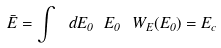Convert formula to latex. <formula><loc_0><loc_0><loc_500><loc_500>\bar { E } = \int \ d E _ { 0 } \ E _ { 0 } \ W _ { E } ( E _ { 0 } ) = E _ { c }</formula> 